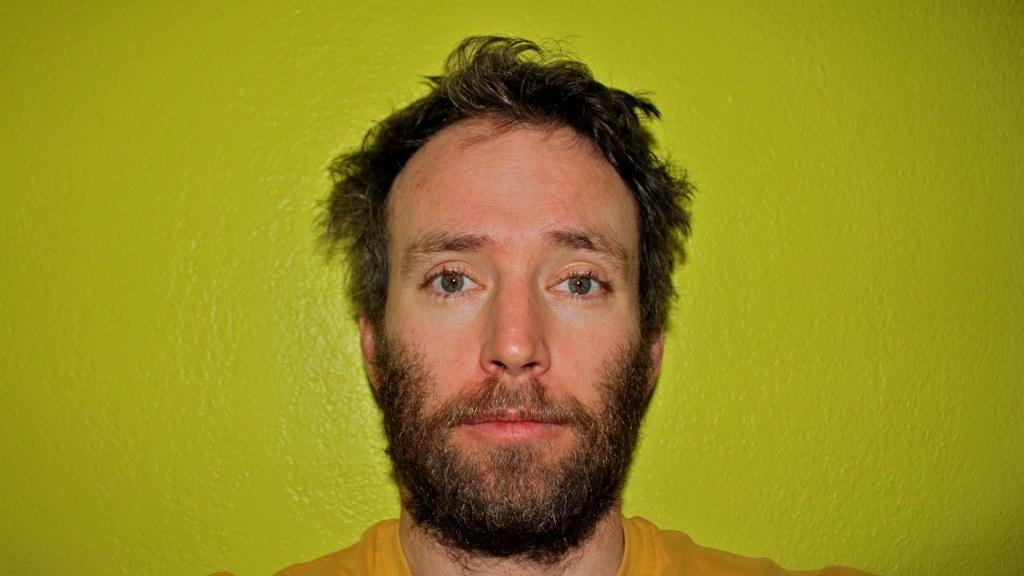Who or what is present in the image? There is a person in the image. What is the person wearing? The person is wearing a yellow t-shirt. What can be seen on the wall in the background of the image? There is a green painting on the wall in the background of the image. How does the person use the bait in the image? There is no bait present in the image, so it cannot be used by the person. 